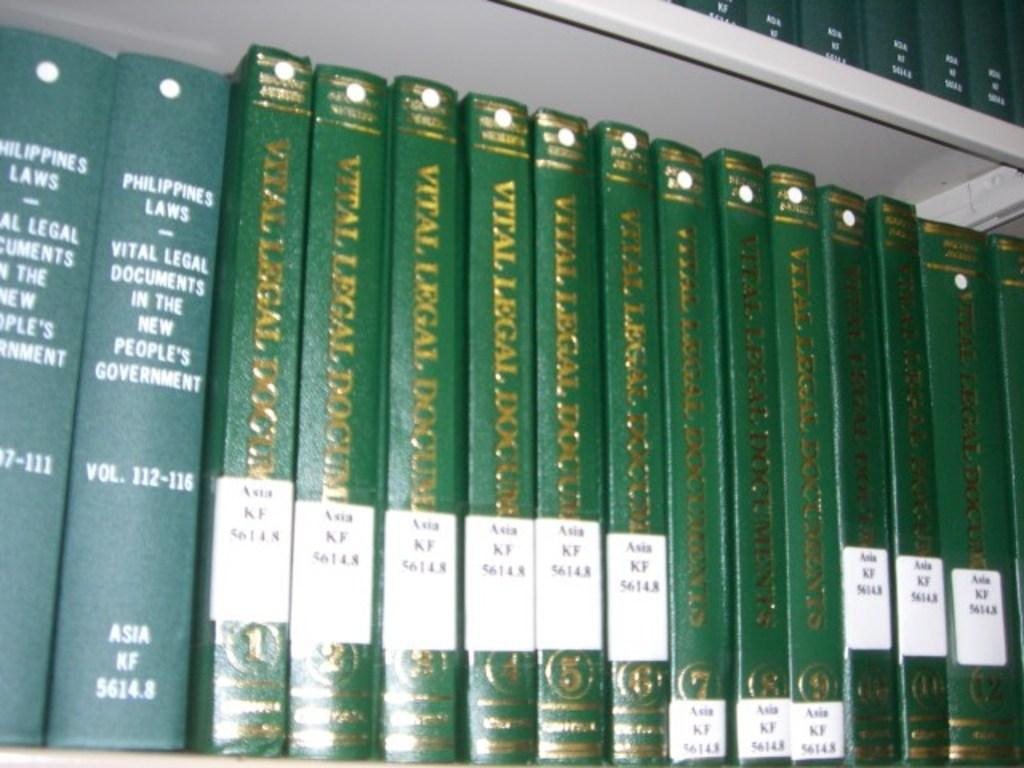<image>
Write a terse but informative summary of the picture. the group of green colored books placed in a rack which has the collection of Philippines laws and vital legal documents 